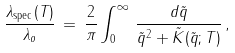Convert formula to latex. <formula><loc_0><loc_0><loc_500><loc_500>\frac { \lambda _ { \text {spec} } ( T ) } { \lambda _ { o } } \, = \, \frac { 2 } { \pi } \int _ { 0 } ^ { \infty } \, \frac { d \tilde { q } } { \tilde { q } ^ { 2 } + \tilde { K } ( \tilde { q } ; T ) } \, ,</formula> 